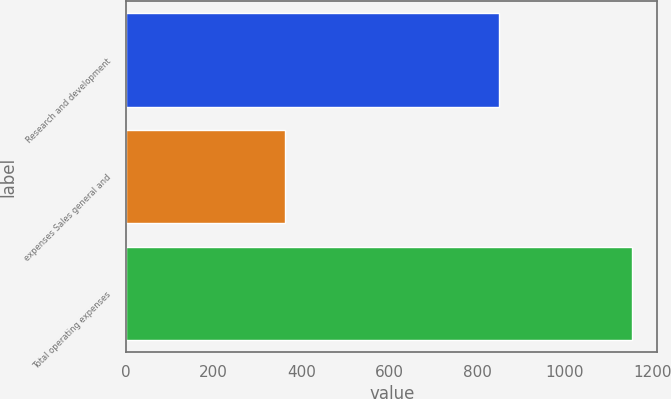Convert chart. <chart><loc_0><loc_0><loc_500><loc_500><bar_chart><fcel>Research and development<fcel>expenses Sales general and<fcel>Total operating expenses<nl><fcel>848.8<fcel>361.5<fcel>1153.3<nl></chart> 